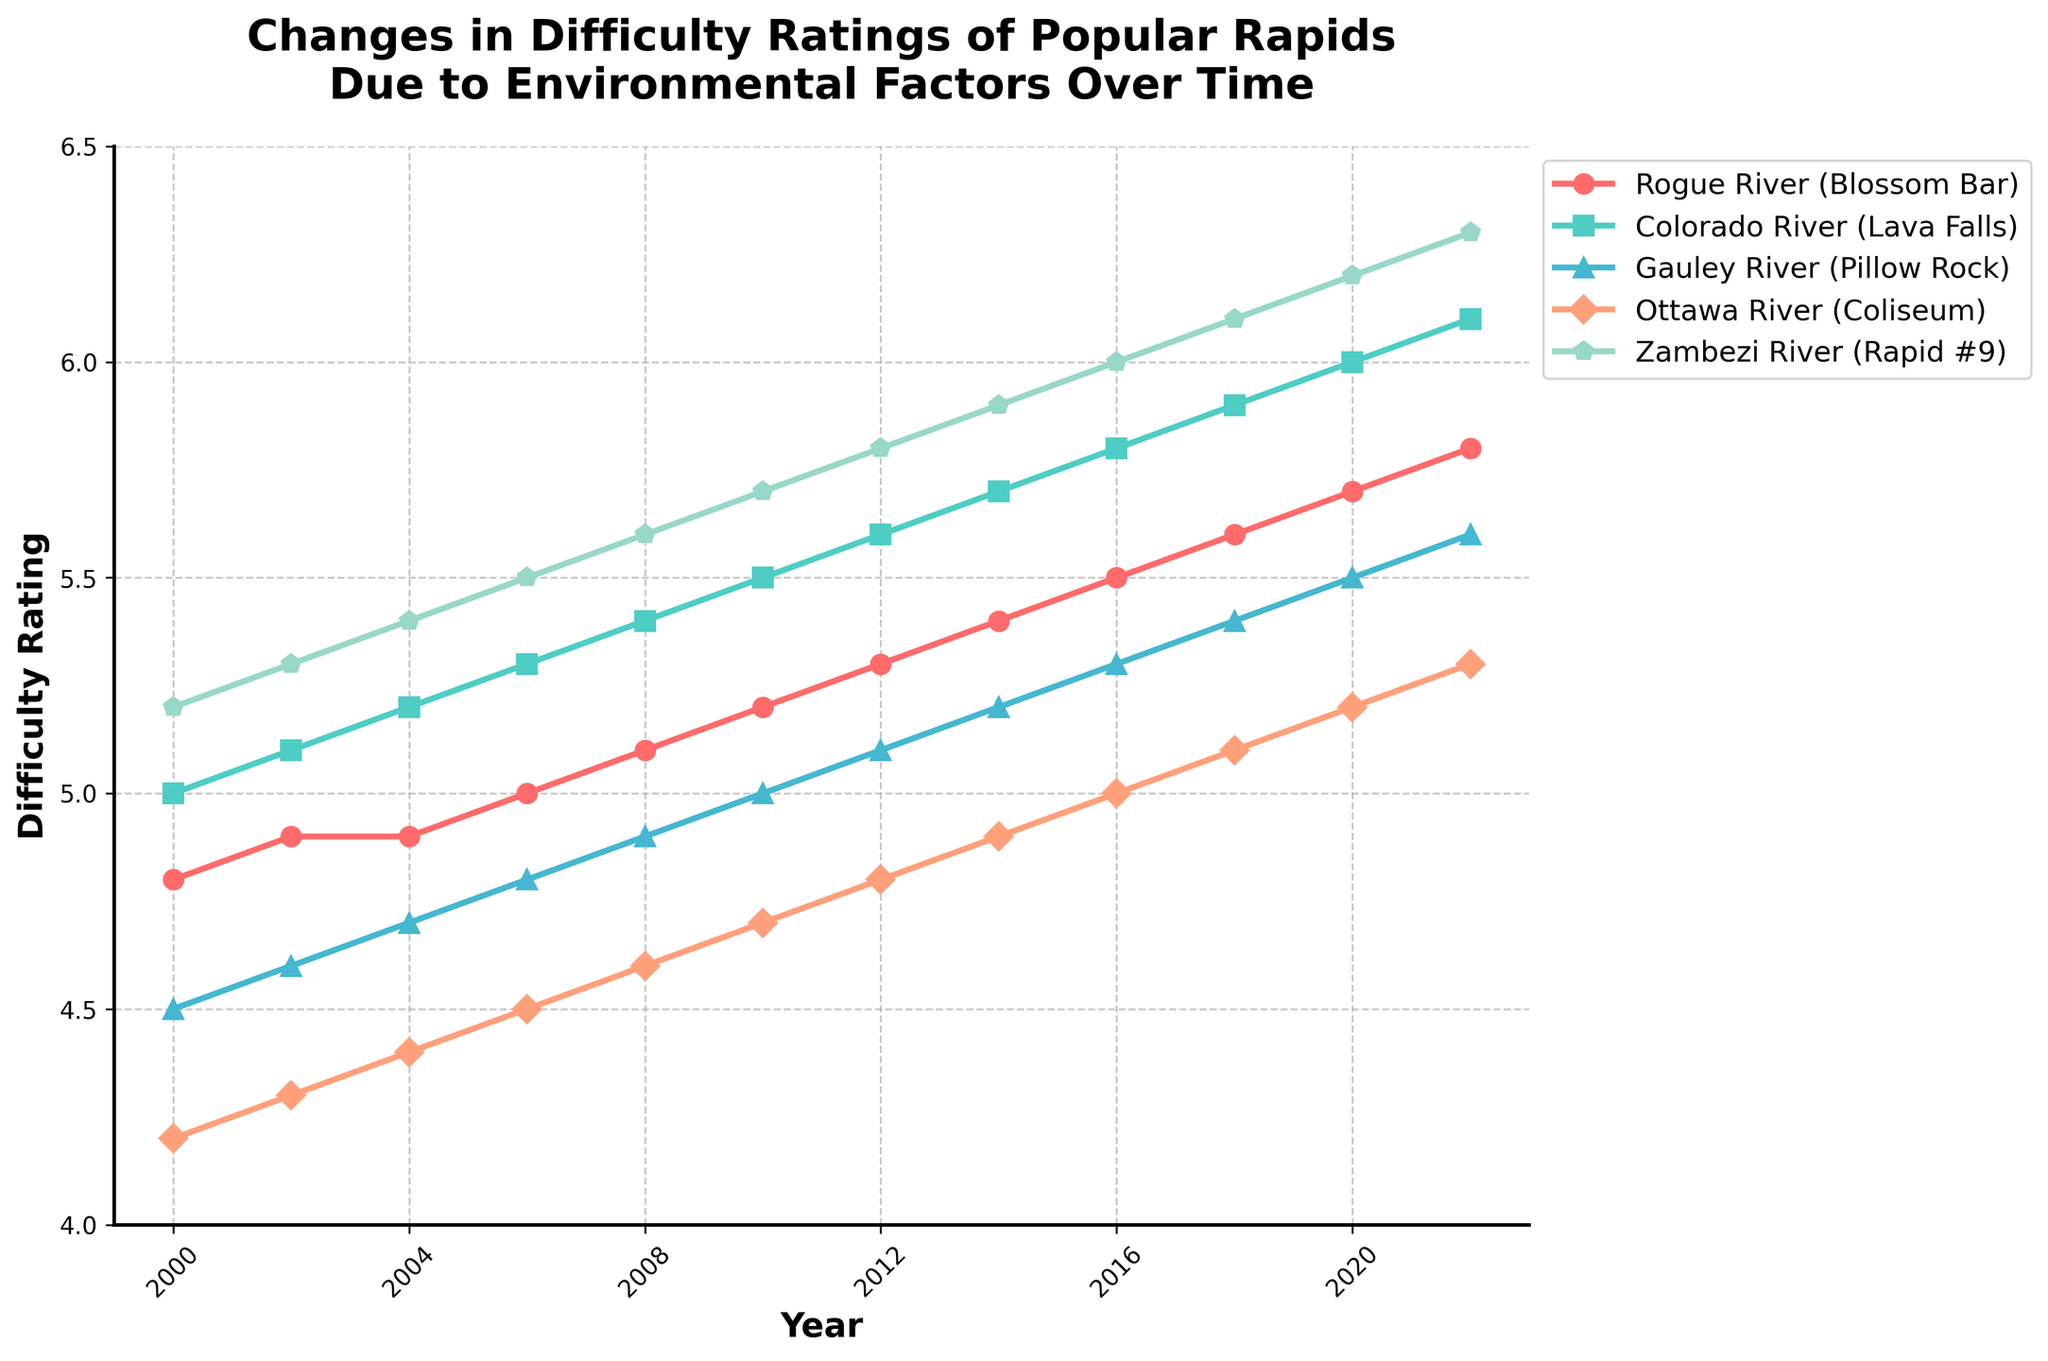Compare the difficulty rating of the Rogue River (Blossom Bar) and the Gauley River (Pillow Rock) in 2010. Which one had a higher rating? In the figure, the Rogue River (Blossom Bar) in 2010 has a difficulty rating of approximately 5.2, while the Gauley River (Pillow Rock) has a rating of 5.0. Hence, the Rogue River (Blossom Bar) had a higher rating.
Answer: Rogue River (Blossom Bar) Which rapid had the highest difficulty rating in 2000? In the figure, look for the highest point on the 2000 vertical line. The highest rating in 2000 was the Zambezi River (Rapid #9) with a rating of approximately 5.2.
Answer: Zambezi River (Rapid #9) What's the difference in the difficulty rating of the Colorado River (Lava Falls) between 2006 and 2022? In the figure, the rating for the Colorado River (Lava Falls) was 5.3 in 2006 and 6.1 in 2022. The difference is 6.1 - 5.3 = 0.8.
Answer: 0.8 How has the difficulty rating of Ottawa River (Coliseum) changed from 2000 to 2022? The difficulty rating of the Ottawa River (Coliseum) in 2000 was 4.2 and increased to 5.3 by 2022. The change in difficulty rating is 5.3 - 4.2 = 1.1.
Answer: Increased by 1.1 What is the average difficulty rating of the Zambezi River (Rapid #9) over the years available in the data? The difficulty ratings for the Zambezi River (Rapid #9) are: 5.2, 5.3, 5.4, 5.5, 5.6, 5.7, 5.8, 5.9, 6.0, 6.1, 6.2, 6.3. The average is calculated as (5.2 + 5.3 + 5.4 + 5.5 + 5.6 + 5.7 + 5.8 + 5.9 + 6.0 + 6.1 + 6.2 + 6.3) / 12 = 5.725.
Answer: 5.725 Which rapid shows the steepest increase in difficulty rating from 2006 to 2010? Evaluate the slopes for each rapid between 2006 and 2010. The Zambezi River (Rapid #9) shows the steepest increase, rising from 5.5 to 5.7, a change of 0.2.
Answer: Zambezi River (Rapid #9) Compare the difficulty rating of all rapids in 2020. Which one has the lowest rating? In the figure, look at the ratings of all rapids in 2020. The Ottawa River (Coliseum) has the lowest rating with a value of 5.2.
Answer: Ottawa River (Coliseum) What trend can be observed in the difficulty ratings of the Gauley River (Pillow Rock) from 2000 to 2022? The difficulty ratings for the Gauley River (Pillow Rock) show a consistent upward trend from 4.5 in 2000 to 5.6 in 2022, indicating a gradual increase over time.
Answer: Gradual increase What is the average difficulty rating of the Rogue River (Blossom Bar) over the years available in the data? The difficulty ratings for the Rogue River (Blossom Bar) are: 4.8, 4.9, 4.9, 5.0, 5.1, 5.2, 5.3, 5.4, 5.5, 5.6, 5.7, 5.8. The average is calculated as (4.8 + 4.9 + 4.9 + 5.0 + 5.1 + 5.2 + 5.3 + 5.4 + 5.5 + 5.6 + 5.7 + 5.8) / 12 = 5.2833
Answer: 5.2833 